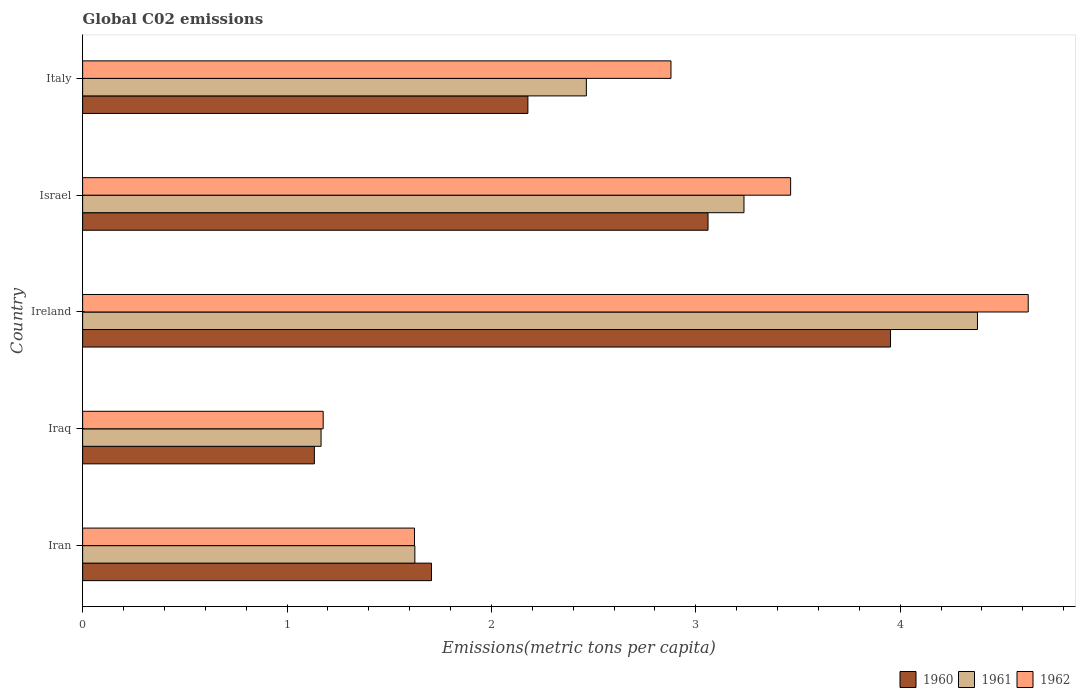Are the number of bars on each tick of the Y-axis equal?
Your answer should be compact. Yes. How many bars are there on the 5th tick from the bottom?
Make the answer very short. 3. What is the label of the 1st group of bars from the top?
Provide a short and direct response. Italy. In how many cases, is the number of bars for a given country not equal to the number of legend labels?
Keep it short and to the point. 0. What is the amount of CO2 emitted in in 1962 in Israel?
Your answer should be compact. 3.46. Across all countries, what is the maximum amount of CO2 emitted in in 1961?
Your response must be concise. 4.38. Across all countries, what is the minimum amount of CO2 emitted in in 1962?
Your response must be concise. 1.18. In which country was the amount of CO2 emitted in in 1961 maximum?
Ensure brevity in your answer.  Ireland. In which country was the amount of CO2 emitted in in 1961 minimum?
Keep it short and to the point. Iraq. What is the total amount of CO2 emitted in in 1961 in the graph?
Keep it short and to the point. 12.87. What is the difference between the amount of CO2 emitted in in 1962 in Iran and that in Israel?
Provide a short and direct response. -1.84. What is the difference between the amount of CO2 emitted in in 1962 in Israel and the amount of CO2 emitted in in 1960 in Iran?
Keep it short and to the point. 1.76. What is the average amount of CO2 emitted in in 1962 per country?
Offer a very short reply. 2.75. What is the difference between the amount of CO2 emitted in in 1960 and amount of CO2 emitted in in 1962 in Iraq?
Keep it short and to the point. -0.04. What is the ratio of the amount of CO2 emitted in in 1962 in Iran to that in Israel?
Ensure brevity in your answer.  0.47. What is the difference between the highest and the second highest amount of CO2 emitted in in 1961?
Offer a terse response. 1.14. What is the difference between the highest and the lowest amount of CO2 emitted in in 1962?
Keep it short and to the point. 3.45. Is the sum of the amount of CO2 emitted in in 1960 in Ireland and Italy greater than the maximum amount of CO2 emitted in in 1961 across all countries?
Give a very brief answer. Yes. How many bars are there?
Your answer should be compact. 15. Are all the bars in the graph horizontal?
Offer a very short reply. Yes. How many countries are there in the graph?
Your answer should be very brief. 5. Are the values on the major ticks of X-axis written in scientific E-notation?
Make the answer very short. No. Does the graph contain grids?
Give a very brief answer. No. How many legend labels are there?
Ensure brevity in your answer.  3. What is the title of the graph?
Provide a succinct answer. Global C02 emissions. Does "1994" appear as one of the legend labels in the graph?
Your answer should be compact. No. What is the label or title of the X-axis?
Your answer should be very brief. Emissions(metric tons per capita). What is the Emissions(metric tons per capita) in 1960 in Iran?
Your answer should be very brief. 1.71. What is the Emissions(metric tons per capita) of 1961 in Iran?
Provide a succinct answer. 1.63. What is the Emissions(metric tons per capita) in 1962 in Iran?
Your answer should be compact. 1.62. What is the Emissions(metric tons per capita) in 1960 in Iraq?
Keep it short and to the point. 1.13. What is the Emissions(metric tons per capita) in 1961 in Iraq?
Your response must be concise. 1.17. What is the Emissions(metric tons per capita) of 1962 in Iraq?
Provide a succinct answer. 1.18. What is the Emissions(metric tons per capita) of 1960 in Ireland?
Provide a succinct answer. 3.95. What is the Emissions(metric tons per capita) of 1961 in Ireland?
Offer a very short reply. 4.38. What is the Emissions(metric tons per capita) of 1962 in Ireland?
Keep it short and to the point. 4.63. What is the Emissions(metric tons per capita) in 1960 in Israel?
Provide a succinct answer. 3.06. What is the Emissions(metric tons per capita) in 1961 in Israel?
Your response must be concise. 3.24. What is the Emissions(metric tons per capita) of 1962 in Israel?
Provide a short and direct response. 3.46. What is the Emissions(metric tons per capita) in 1960 in Italy?
Offer a terse response. 2.18. What is the Emissions(metric tons per capita) of 1961 in Italy?
Your answer should be compact. 2.46. What is the Emissions(metric tons per capita) in 1962 in Italy?
Offer a very short reply. 2.88. Across all countries, what is the maximum Emissions(metric tons per capita) in 1960?
Keep it short and to the point. 3.95. Across all countries, what is the maximum Emissions(metric tons per capita) in 1961?
Your answer should be compact. 4.38. Across all countries, what is the maximum Emissions(metric tons per capita) of 1962?
Provide a short and direct response. 4.63. Across all countries, what is the minimum Emissions(metric tons per capita) in 1960?
Offer a terse response. 1.13. Across all countries, what is the minimum Emissions(metric tons per capita) of 1961?
Provide a succinct answer. 1.17. Across all countries, what is the minimum Emissions(metric tons per capita) in 1962?
Offer a terse response. 1.18. What is the total Emissions(metric tons per capita) in 1960 in the graph?
Give a very brief answer. 12.03. What is the total Emissions(metric tons per capita) in 1961 in the graph?
Ensure brevity in your answer.  12.87. What is the total Emissions(metric tons per capita) in 1962 in the graph?
Provide a succinct answer. 13.77. What is the difference between the Emissions(metric tons per capita) in 1960 in Iran and that in Iraq?
Your response must be concise. 0.57. What is the difference between the Emissions(metric tons per capita) in 1961 in Iran and that in Iraq?
Give a very brief answer. 0.46. What is the difference between the Emissions(metric tons per capita) in 1962 in Iran and that in Iraq?
Provide a short and direct response. 0.45. What is the difference between the Emissions(metric tons per capita) of 1960 in Iran and that in Ireland?
Offer a terse response. -2.25. What is the difference between the Emissions(metric tons per capita) of 1961 in Iran and that in Ireland?
Provide a succinct answer. -2.75. What is the difference between the Emissions(metric tons per capita) in 1962 in Iran and that in Ireland?
Provide a succinct answer. -3. What is the difference between the Emissions(metric tons per capita) in 1960 in Iran and that in Israel?
Keep it short and to the point. -1.35. What is the difference between the Emissions(metric tons per capita) in 1961 in Iran and that in Israel?
Offer a very short reply. -1.61. What is the difference between the Emissions(metric tons per capita) in 1962 in Iran and that in Israel?
Offer a very short reply. -1.84. What is the difference between the Emissions(metric tons per capita) in 1960 in Iran and that in Italy?
Keep it short and to the point. -0.47. What is the difference between the Emissions(metric tons per capita) of 1961 in Iran and that in Italy?
Your answer should be compact. -0.84. What is the difference between the Emissions(metric tons per capita) in 1962 in Iran and that in Italy?
Your answer should be very brief. -1.25. What is the difference between the Emissions(metric tons per capita) of 1960 in Iraq and that in Ireland?
Give a very brief answer. -2.82. What is the difference between the Emissions(metric tons per capita) in 1961 in Iraq and that in Ireland?
Your answer should be compact. -3.21. What is the difference between the Emissions(metric tons per capita) of 1962 in Iraq and that in Ireland?
Offer a very short reply. -3.45. What is the difference between the Emissions(metric tons per capita) of 1960 in Iraq and that in Israel?
Provide a succinct answer. -1.93. What is the difference between the Emissions(metric tons per capita) in 1961 in Iraq and that in Israel?
Provide a short and direct response. -2.07. What is the difference between the Emissions(metric tons per capita) in 1962 in Iraq and that in Israel?
Give a very brief answer. -2.29. What is the difference between the Emissions(metric tons per capita) in 1960 in Iraq and that in Italy?
Your answer should be compact. -1.04. What is the difference between the Emissions(metric tons per capita) of 1961 in Iraq and that in Italy?
Your answer should be very brief. -1.3. What is the difference between the Emissions(metric tons per capita) of 1962 in Iraq and that in Italy?
Provide a succinct answer. -1.7. What is the difference between the Emissions(metric tons per capita) in 1960 in Ireland and that in Israel?
Ensure brevity in your answer.  0.89. What is the difference between the Emissions(metric tons per capita) of 1961 in Ireland and that in Israel?
Give a very brief answer. 1.14. What is the difference between the Emissions(metric tons per capita) of 1962 in Ireland and that in Israel?
Offer a terse response. 1.16. What is the difference between the Emissions(metric tons per capita) of 1960 in Ireland and that in Italy?
Your answer should be compact. 1.77. What is the difference between the Emissions(metric tons per capita) in 1961 in Ireland and that in Italy?
Keep it short and to the point. 1.91. What is the difference between the Emissions(metric tons per capita) in 1962 in Ireland and that in Italy?
Provide a succinct answer. 1.75. What is the difference between the Emissions(metric tons per capita) in 1960 in Israel and that in Italy?
Offer a terse response. 0.88. What is the difference between the Emissions(metric tons per capita) of 1961 in Israel and that in Italy?
Provide a succinct answer. 0.77. What is the difference between the Emissions(metric tons per capita) in 1962 in Israel and that in Italy?
Give a very brief answer. 0.59. What is the difference between the Emissions(metric tons per capita) in 1960 in Iran and the Emissions(metric tons per capita) in 1961 in Iraq?
Ensure brevity in your answer.  0.54. What is the difference between the Emissions(metric tons per capita) of 1960 in Iran and the Emissions(metric tons per capita) of 1962 in Iraq?
Your answer should be very brief. 0.53. What is the difference between the Emissions(metric tons per capita) in 1961 in Iran and the Emissions(metric tons per capita) in 1962 in Iraq?
Provide a short and direct response. 0.45. What is the difference between the Emissions(metric tons per capita) of 1960 in Iran and the Emissions(metric tons per capita) of 1961 in Ireland?
Make the answer very short. -2.67. What is the difference between the Emissions(metric tons per capita) of 1960 in Iran and the Emissions(metric tons per capita) of 1962 in Ireland?
Make the answer very short. -2.92. What is the difference between the Emissions(metric tons per capita) in 1961 in Iran and the Emissions(metric tons per capita) in 1962 in Ireland?
Your response must be concise. -3. What is the difference between the Emissions(metric tons per capita) in 1960 in Iran and the Emissions(metric tons per capita) in 1961 in Israel?
Give a very brief answer. -1.53. What is the difference between the Emissions(metric tons per capita) in 1960 in Iran and the Emissions(metric tons per capita) in 1962 in Israel?
Offer a terse response. -1.76. What is the difference between the Emissions(metric tons per capita) in 1961 in Iran and the Emissions(metric tons per capita) in 1962 in Israel?
Offer a very short reply. -1.84. What is the difference between the Emissions(metric tons per capita) of 1960 in Iran and the Emissions(metric tons per capita) of 1961 in Italy?
Offer a terse response. -0.76. What is the difference between the Emissions(metric tons per capita) of 1960 in Iran and the Emissions(metric tons per capita) of 1962 in Italy?
Make the answer very short. -1.17. What is the difference between the Emissions(metric tons per capita) in 1961 in Iran and the Emissions(metric tons per capita) in 1962 in Italy?
Your answer should be compact. -1.25. What is the difference between the Emissions(metric tons per capita) in 1960 in Iraq and the Emissions(metric tons per capita) in 1961 in Ireland?
Provide a short and direct response. -3.24. What is the difference between the Emissions(metric tons per capita) of 1960 in Iraq and the Emissions(metric tons per capita) of 1962 in Ireland?
Give a very brief answer. -3.49. What is the difference between the Emissions(metric tons per capita) in 1961 in Iraq and the Emissions(metric tons per capita) in 1962 in Ireland?
Your answer should be very brief. -3.46. What is the difference between the Emissions(metric tons per capita) in 1960 in Iraq and the Emissions(metric tons per capita) in 1961 in Israel?
Provide a short and direct response. -2.1. What is the difference between the Emissions(metric tons per capita) of 1960 in Iraq and the Emissions(metric tons per capita) of 1962 in Israel?
Offer a very short reply. -2.33. What is the difference between the Emissions(metric tons per capita) in 1961 in Iraq and the Emissions(metric tons per capita) in 1962 in Israel?
Your answer should be compact. -2.3. What is the difference between the Emissions(metric tons per capita) in 1960 in Iraq and the Emissions(metric tons per capita) in 1961 in Italy?
Provide a short and direct response. -1.33. What is the difference between the Emissions(metric tons per capita) in 1960 in Iraq and the Emissions(metric tons per capita) in 1962 in Italy?
Offer a terse response. -1.74. What is the difference between the Emissions(metric tons per capita) in 1961 in Iraq and the Emissions(metric tons per capita) in 1962 in Italy?
Provide a short and direct response. -1.71. What is the difference between the Emissions(metric tons per capita) in 1960 in Ireland and the Emissions(metric tons per capita) in 1961 in Israel?
Your answer should be very brief. 0.72. What is the difference between the Emissions(metric tons per capita) of 1960 in Ireland and the Emissions(metric tons per capita) of 1962 in Israel?
Your response must be concise. 0.49. What is the difference between the Emissions(metric tons per capita) in 1961 in Ireland and the Emissions(metric tons per capita) in 1962 in Israel?
Your answer should be compact. 0.91. What is the difference between the Emissions(metric tons per capita) of 1960 in Ireland and the Emissions(metric tons per capita) of 1961 in Italy?
Your answer should be compact. 1.49. What is the difference between the Emissions(metric tons per capita) of 1960 in Ireland and the Emissions(metric tons per capita) of 1962 in Italy?
Provide a succinct answer. 1.07. What is the difference between the Emissions(metric tons per capita) in 1961 in Ireland and the Emissions(metric tons per capita) in 1962 in Italy?
Your answer should be very brief. 1.5. What is the difference between the Emissions(metric tons per capita) of 1960 in Israel and the Emissions(metric tons per capita) of 1961 in Italy?
Your answer should be very brief. 0.6. What is the difference between the Emissions(metric tons per capita) in 1960 in Israel and the Emissions(metric tons per capita) in 1962 in Italy?
Provide a succinct answer. 0.18. What is the difference between the Emissions(metric tons per capita) of 1961 in Israel and the Emissions(metric tons per capita) of 1962 in Italy?
Offer a very short reply. 0.36. What is the average Emissions(metric tons per capita) of 1960 per country?
Give a very brief answer. 2.41. What is the average Emissions(metric tons per capita) of 1961 per country?
Your response must be concise. 2.57. What is the average Emissions(metric tons per capita) in 1962 per country?
Give a very brief answer. 2.75. What is the difference between the Emissions(metric tons per capita) of 1960 and Emissions(metric tons per capita) of 1961 in Iran?
Your response must be concise. 0.08. What is the difference between the Emissions(metric tons per capita) in 1960 and Emissions(metric tons per capita) in 1962 in Iran?
Give a very brief answer. 0.08. What is the difference between the Emissions(metric tons per capita) in 1961 and Emissions(metric tons per capita) in 1962 in Iran?
Offer a very short reply. 0. What is the difference between the Emissions(metric tons per capita) of 1960 and Emissions(metric tons per capita) of 1961 in Iraq?
Offer a terse response. -0.03. What is the difference between the Emissions(metric tons per capita) in 1960 and Emissions(metric tons per capita) in 1962 in Iraq?
Keep it short and to the point. -0.04. What is the difference between the Emissions(metric tons per capita) in 1961 and Emissions(metric tons per capita) in 1962 in Iraq?
Ensure brevity in your answer.  -0.01. What is the difference between the Emissions(metric tons per capita) in 1960 and Emissions(metric tons per capita) in 1961 in Ireland?
Make the answer very short. -0.43. What is the difference between the Emissions(metric tons per capita) of 1960 and Emissions(metric tons per capita) of 1962 in Ireland?
Give a very brief answer. -0.67. What is the difference between the Emissions(metric tons per capita) of 1961 and Emissions(metric tons per capita) of 1962 in Ireland?
Provide a short and direct response. -0.25. What is the difference between the Emissions(metric tons per capita) of 1960 and Emissions(metric tons per capita) of 1961 in Israel?
Your response must be concise. -0.18. What is the difference between the Emissions(metric tons per capita) in 1960 and Emissions(metric tons per capita) in 1962 in Israel?
Offer a terse response. -0.4. What is the difference between the Emissions(metric tons per capita) of 1961 and Emissions(metric tons per capita) of 1962 in Israel?
Your response must be concise. -0.23. What is the difference between the Emissions(metric tons per capita) in 1960 and Emissions(metric tons per capita) in 1961 in Italy?
Give a very brief answer. -0.29. What is the difference between the Emissions(metric tons per capita) in 1960 and Emissions(metric tons per capita) in 1962 in Italy?
Your answer should be very brief. -0.7. What is the difference between the Emissions(metric tons per capita) of 1961 and Emissions(metric tons per capita) of 1962 in Italy?
Make the answer very short. -0.41. What is the ratio of the Emissions(metric tons per capita) in 1960 in Iran to that in Iraq?
Offer a very short reply. 1.51. What is the ratio of the Emissions(metric tons per capita) of 1961 in Iran to that in Iraq?
Provide a short and direct response. 1.39. What is the ratio of the Emissions(metric tons per capita) in 1962 in Iran to that in Iraq?
Ensure brevity in your answer.  1.38. What is the ratio of the Emissions(metric tons per capita) in 1960 in Iran to that in Ireland?
Provide a short and direct response. 0.43. What is the ratio of the Emissions(metric tons per capita) in 1961 in Iran to that in Ireland?
Make the answer very short. 0.37. What is the ratio of the Emissions(metric tons per capita) of 1962 in Iran to that in Ireland?
Offer a very short reply. 0.35. What is the ratio of the Emissions(metric tons per capita) in 1960 in Iran to that in Israel?
Offer a very short reply. 0.56. What is the ratio of the Emissions(metric tons per capita) in 1961 in Iran to that in Israel?
Keep it short and to the point. 0.5. What is the ratio of the Emissions(metric tons per capita) of 1962 in Iran to that in Israel?
Your answer should be compact. 0.47. What is the ratio of the Emissions(metric tons per capita) in 1960 in Iran to that in Italy?
Your answer should be compact. 0.78. What is the ratio of the Emissions(metric tons per capita) of 1961 in Iran to that in Italy?
Offer a terse response. 0.66. What is the ratio of the Emissions(metric tons per capita) of 1962 in Iran to that in Italy?
Your answer should be very brief. 0.56. What is the ratio of the Emissions(metric tons per capita) in 1960 in Iraq to that in Ireland?
Your answer should be very brief. 0.29. What is the ratio of the Emissions(metric tons per capita) of 1961 in Iraq to that in Ireland?
Keep it short and to the point. 0.27. What is the ratio of the Emissions(metric tons per capita) in 1962 in Iraq to that in Ireland?
Your answer should be compact. 0.25. What is the ratio of the Emissions(metric tons per capita) in 1960 in Iraq to that in Israel?
Your answer should be very brief. 0.37. What is the ratio of the Emissions(metric tons per capita) of 1961 in Iraq to that in Israel?
Your answer should be very brief. 0.36. What is the ratio of the Emissions(metric tons per capita) in 1962 in Iraq to that in Israel?
Your answer should be compact. 0.34. What is the ratio of the Emissions(metric tons per capita) in 1960 in Iraq to that in Italy?
Make the answer very short. 0.52. What is the ratio of the Emissions(metric tons per capita) of 1961 in Iraq to that in Italy?
Make the answer very short. 0.47. What is the ratio of the Emissions(metric tons per capita) of 1962 in Iraq to that in Italy?
Give a very brief answer. 0.41. What is the ratio of the Emissions(metric tons per capita) in 1960 in Ireland to that in Israel?
Your answer should be very brief. 1.29. What is the ratio of the Emissions(metric tons per capita) of 1961 in Ireland to that in Israel?
Offer a terse response. 1.35. What is the ratio of the Emissions(metric tons per capita) in 1962 in Ireland to that in Israel?
Your answer should be compact. 1.34. What is the ratio of the Emissions(metric tons per capita) of 1960 in Ireland to that in Italy?
Provide a short and direct response. 1.81. What is the ratio of the Emissions(metric tons per capita) in 1961 in Ireland to that in Italy?
Provide a short and direct response. 1.78. What is the ratio of the Emissions(metric tons per capita) in 1962 in Ireland to that in Italy?
Keep it short and to the point. 1.61. What is the ratio of the Emissions(metric tons per capita) of 1960 in Israel to that in Italy?
Offer a very short reply. 1.4. What is the ratio of the Emissions(metric tons per capita) of 1961 in Israel to that in Italy?
Provide a succinct answer. 1.31. What is the ratio of the Emissions(metric tons per capita) in 1962 in Israel to that in Italy?
Provide a short and direct response. 1.2. What is the difference between the highest and the second highest Emissions(metric tons per capita) of 1960?
Provide a short and direct response. 0.89. What is the difference between the highest and the second highest Emissions(metric tons per capita) in 1961?
Your answer should be very brief. 1.14. What is the difference between the highest and the second highest Emissions(metric tons per capita) of 1962?
Keep it short and to the point. 1.16. What is the difference between the highest and the lowest Emissions(metric tons per capita) of 1960?
Offer a very short reply. 2.82. What is the difference between the highest and the lowest Emissions(metric tons per capita) in 1961?
Offer a very short reply. 3.21. What is the difference between the highest and the lowest Emissions(metric tons per capita) of 1962?
Offer a terse response. 3.45. 